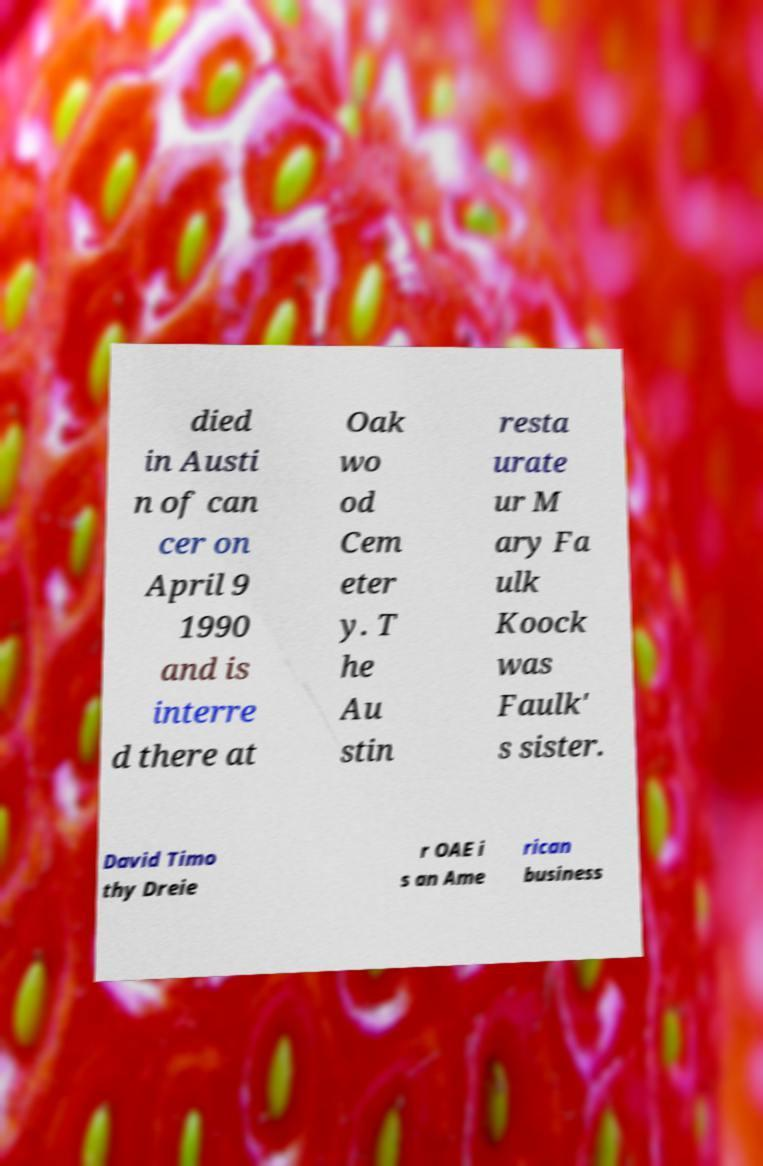What messages or text are displayed in this image? I need them in a readable, typed format. died in Austi n of can cer on April 9 1990 and is interre d there at Oak wo od Cem eter y. T he Au stin resta urate ur M ary Fa ulk Koock was Faulk' s sister. David Timo thy Dreie r OAE i s an Ame rican business 